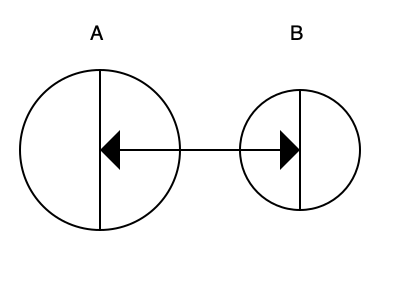In a textile spinning machine, two interlocking gears are shown above. If gear A rotates clockwise, in which direction will gear B rotate? To determine the rotation direction of gear B, we need to follow these steps:

1. Identify the given information:
   - Gear A is rotating clockwise
   - The gears are interlocking

2. Understand the principle of interlocking gears:
   - When two gears interlock, they rotate in opposite directions
   - The point of contact between the gears moves in the same direction for both gears

3. Analyze the rotation of gear A:
   - Gear A is rotating clockwise
   - This means the teeth on the right side of gear A are moving downward

4. Determine the effect on gear B:
   - As gear A's teeth move downward on the right, they push gear B's teeth upward
   - This upward force on the left side of gear B causes it to rotate counterclockwise

5. Verify the result:
   - Imagine tracing the point of contact between the gears
   - You'll see that this point moves downward for both gears, confirming the opposite rotation

Therefore, when gear A rotates clockwise, gear B will rotate counterclockwise.
Answer: Counterclockwise 